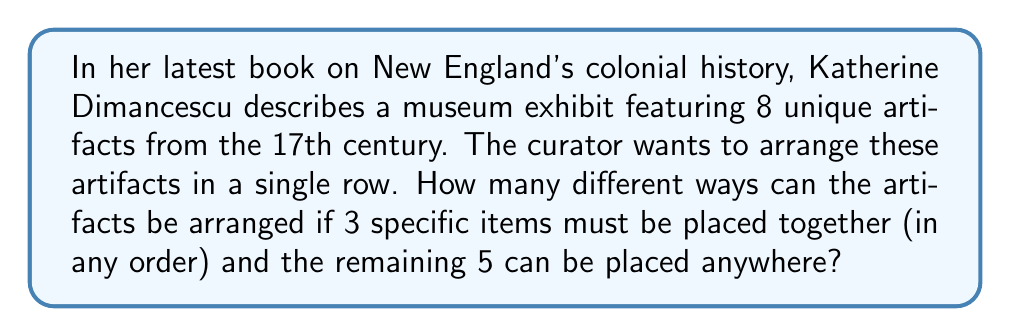Show me your answer to this math problem. Let's approach this step-by-step:

1) First, we can consider the 3 specific items that must be placed together as one unit. So now we essentially have 6 items to arrange: the group of 3 and the other 5 individual items.

2) The number of ways to arrange 6 items is a straightforward permutation:
   $$ P(6,6) = 6! = 6 \times 5 \times 4 \times 3 \times 2 \times 1 = 720 $$

3) However, we're not done yet. Remember that the 3 items within the group can also be arranged in different ways. This is another permutation:
   $$ P(3,3) = 3! = 3 \times 2 \times 1 = 6 $$

4) By the multiplication principle, we multiply these results together:
   $$ 720 \times 6 = 4,320 $$

This gives us the total number of possible arrangements.

The reasoning behind this approach aligns with Dimancescu's emphasis on the importance of contextualizing historical artifacts. Just as she encourages readers to consider artifacts in relation to each other, this problem requires us to think about how the grouping of certain items affects the overall arrangement.
Answer: 4,320 different arrangements 